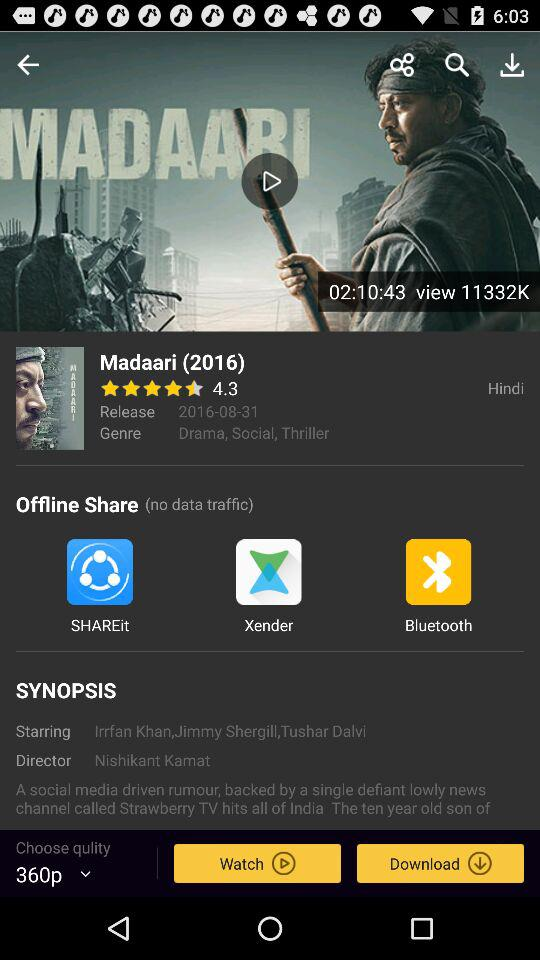What is the selected quality? The selected quality is "360p". 